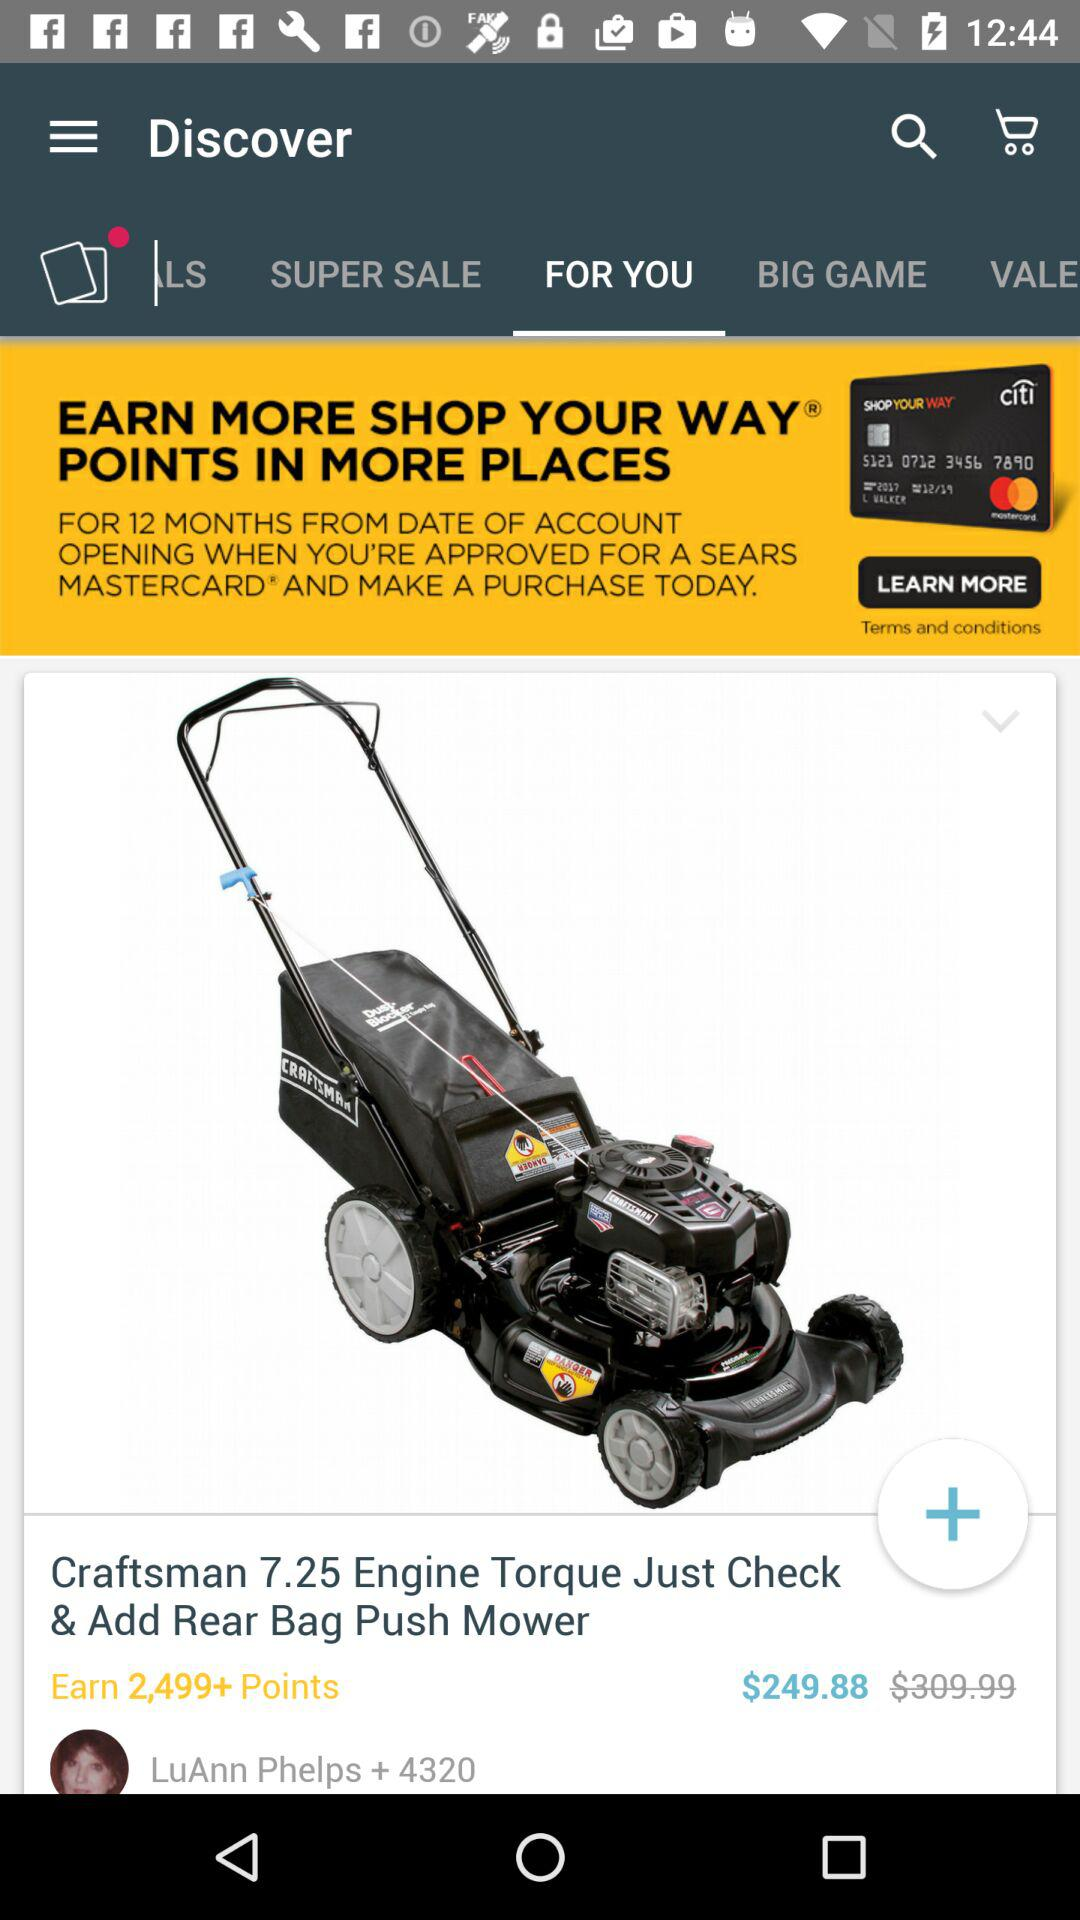What is the price for the "Craftsman 7.25 Engine Torque"? The price is $249.88. 